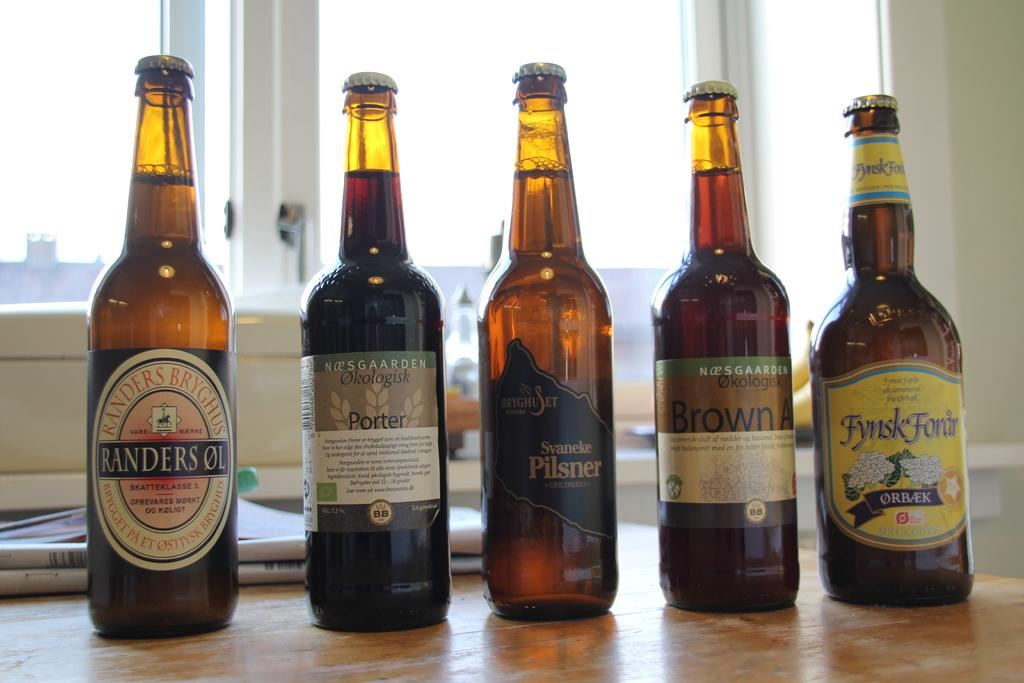<image>
Write a terse but informative summary of the picture. five amber beer bottles with labels such as fynk forar and randers ol 